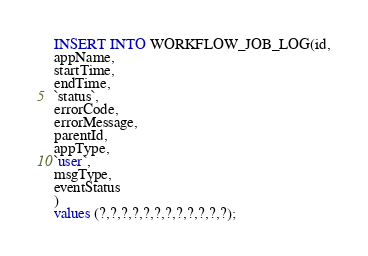Convert code to text. <code><loc_0><loc_0><loc_500><loc_500><_SQL_>INSERT INTO WORKFLOW_JOB_LOG(id,
appName,
startTime,
endTime,
`status`,
errorCode,
errorMessage,
parentId,
appType,
`user`,
msgType,
eventStatus
)
values (?,?,?,?,?,?,?,?,?,?,?,?);
</code> 